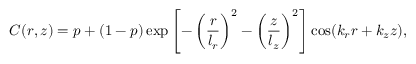<formula> <loc_0><loc_0><loc_500><loc_500>C ( r , z ) = p + ( 1 - p ) \exp \left [ - \left ( \frac { r } { l _ { r } } \right ) ^ { 2 } - \left ( \frac { z } { l _ { z } } \right ) ^ { 2 } \right ] \cos ( k _ { r } r + k _ { z } z ) ,</formula> 